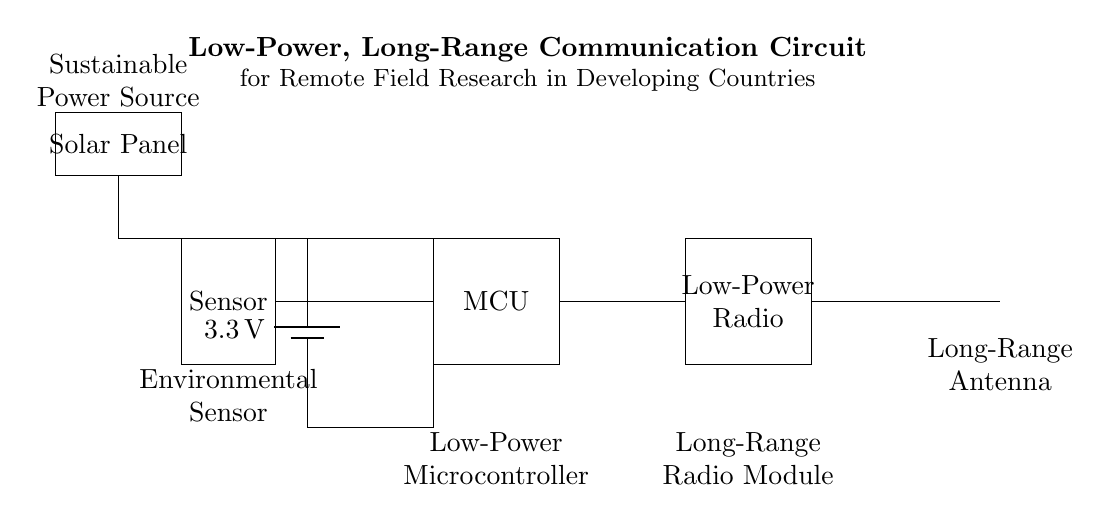What is the voltage supplied by the power source? The voltage supplied by the power source is indicated as 3.3 volts in the diagram, represented near the battery symbol.
Answer: 3.3 volts What component is connected to the antenna? The Low-Power Radio Module is connected to the antenna as per the indicated connections in the diagram.
Answer: Low-Power Radio Module What type of sensor is shown in the circuit? The component labeled as "Sensor" in the diagram refers to an environmental sensor which can measure various environmental parameters.
Answer: Environmental How is the circuit powered sustainably? The circuit is powered by a solar panel, as indicated in the labeled component on the diagram, providing an eco-friendly power source.
Answer: Solar Panel What is the function of the microcontroller in this circuit? The Low-Power Microcontroller is responsible for processing data collected from the sensor and managing communications with the radio module.
Answer: Data processing How does the voltage flow from the power source to the microcontroller? Voltage flows from the battery, traveling along the line to the microcontroller, which is connected directly at its upper side, demonstrating a direct connection for power.
Answer: Direct connection What is the purpose of the long-range radio module? The long-range radio module is designed to enable communication over long distances, facilitating data transmission from remote locations.
Answer: Data transmission 